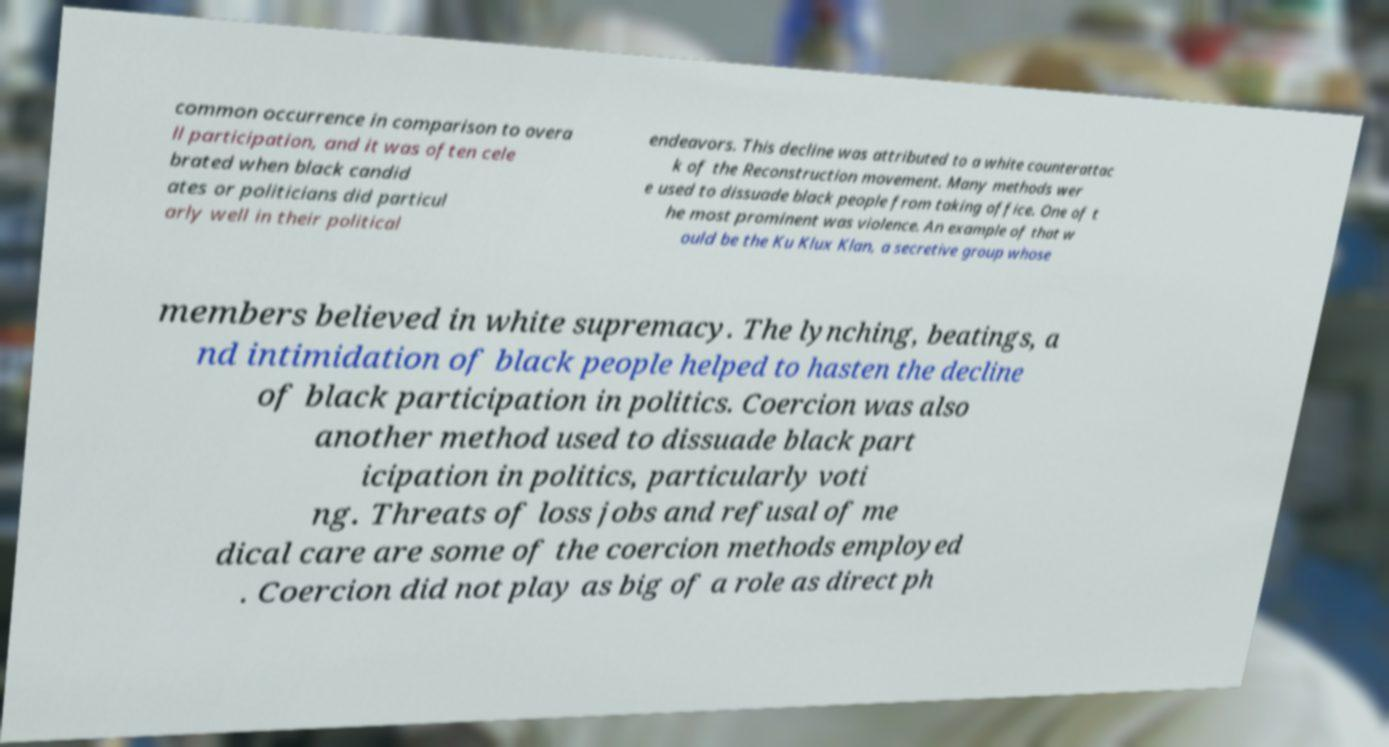Can you read and provide the text displayed in the image?This photo seems to have some interesting text. Can you extract and type it out for me? common occurrence in comparison to overa ll participation, and it was often cele brated when black candid ates or politicians did particul arly well in their political endeavors. This decline was attributed to a white counterattac k of the Reconstruction movement. Many methods wer e used to dissuade black people from taking office. One of t he most prominent was violence. An example of that w ould be the Ku Klux Klan, a secretive group whose members believed in white supremacy. The lynching, beatings, a nd intimidation of black people helped to hasten the decline of black participation in politics. Coercion was also another method used to dissuade black part icipation in politics, particularly voti ng. Threats of loss jobs and refusal of me dical care are some of the coercion methods employed . Coercion did not play as big of a role as direct ph 